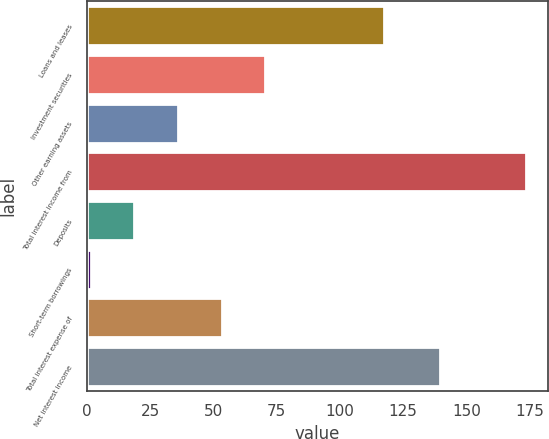Convert chart. <chart><loc_0><loc_0><loc_500><loc_500><bar_chart><fcel>Loans and leases<fcel>Investment securities<fcel>Other earning assets<fcel>Total interest income from<fcel>Deposits<fcel>Short-term borrowings<fcel>Total interest expense of<fcel>Net interest income<nl><fcel>117.6<fcel>70.48<fcel>36.04<fcel>173.8<fcel>18.82<fcel>1.6<fcel>53.26<fcel>139.7<nl></chart> 